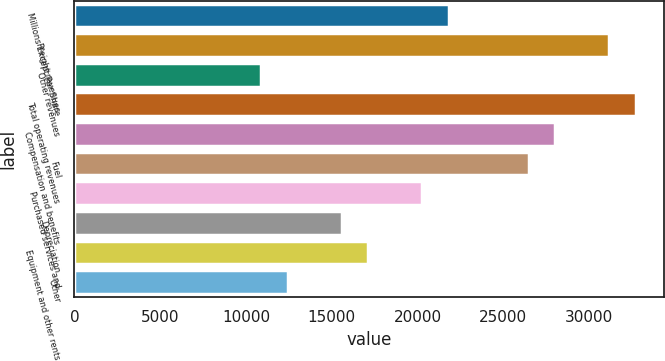Convert chart. <chart><loc_0><loc_0><loc_500><loc_500><bar_chart><fcel>Millions Except Per Share<fcel>Freight revenues<fcel>Other revenues<fcel>Total operating revenues<fcel>Compensation and benefits<fcel>Fuel<fcel>Purchased services and<fcel>Depreciation<fcel>Equipment and other rents<fcel>Other<nl><fcel>21809<fcel>31155.4<fcel>10904.8<fcel>32713.1<fcel>28039.9<fcel>26482.2<fcel>20251.2<fcel>15578<fcel>17135.7<fcel>12462.5<nl></chart> 